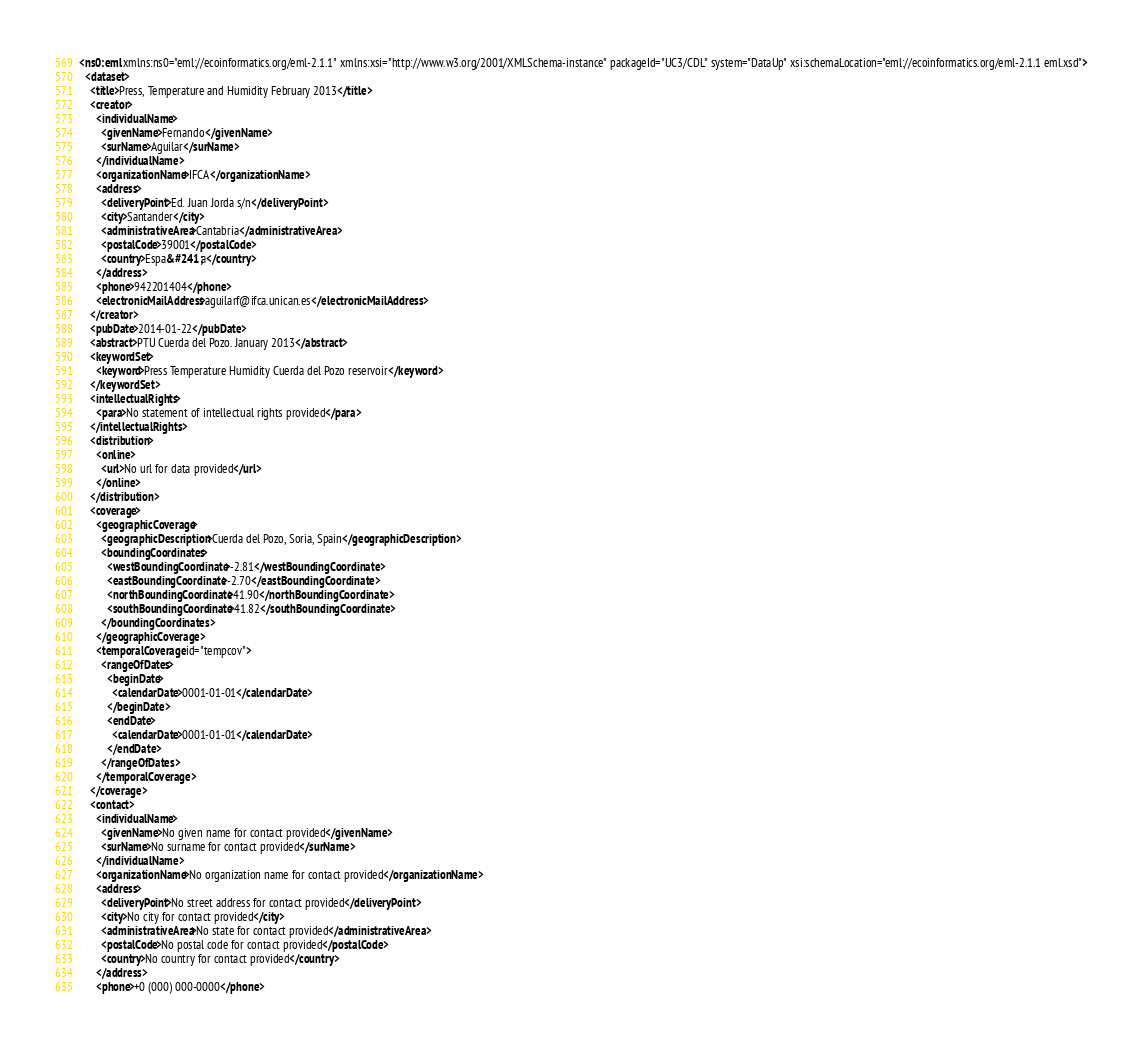Convert code to text. <code><loc_0><loc_0><loc_500><loc_500><_XML_><ns0:eml xmlns:ns0="eml://ecoinformatics.org/eml-2.1.1" xmlns:xsi="http://www.w3.org/2001/XMLSchema-instance" packageId="UC3/CDL" system="DataUp" xsi:schemaLocation="eml://ecoinformatics.org/eml-2.1.1 eml.xsd">
  <dataset>
    <title>Press, Temperature and Humidity February 2013</title>
    <creator>
      <individualName>
        <givenName>Fernando</givenName>
        <surName>Aguilar</surName>
      </individualName>
      <organizationName>IFCA</organizationName>
      <address>
        <deliveryPoint>Ed. Juan Jorda s/n</deliveryPoint>
        <city>Santander</city>
        <administrativeArea>Cantabria</administrativeArea>
        <postalCode>39001</postalCode>
        <country>Espa&#241;a</country>
      </address>
      <phone>942201404</phone>
      <electronicMailAddress>aguilarf@ifca.unican.es</electronicMailAddress>
    </creator>
    <pubDate>2014-01-22</pubDate>
    <abstract>PTU Cuerda del Pozo. January 2013</abstract>
    <keywordSet>
      <keyword>Press Temperature Humidity Cuerda del Pozo reservoir</keyword>
    </keywordSet>
    <intellectualRights>
      <para>No statement of intellectual rights provided</para>
    </intellectualRights>
    <distribution>
      <online>
        <url>No url for data provided</url>
      </online>
    </distribution>
    <coverage>
      <geographicCoverage>
        <geographicDescription>Cuerda del Pozo, Soria, Spain</geographicDescription>
        <boundingCoordinates>
          <westBoundingCoordinate>-2.81</westBoundingCoordinate>
          <eastBoundingCoordinate>-2.70</eastBoundingCoordinate>
          <northBoundingCoordinate>41.90</northBoundingCoordinate>
          <southBoundingCoordinate>41.82</southBoundingCoordinate>
        </boundingCoordinates>
      </geographicCoverage>
      <temporalCoverage id="tempcov">
        <rangeOfDates>
          <beginDate>
            <calendarDate>0001-01-01</calendarDate>
          </beginDate>
          <endDate>
            <calendarDate>0001-01-01</calendarDate>
          </endDate>
        </rangeOfDates>
      </temporalCoverage>
    </coverage>
    <contact>
      <individualName>
        <givenName>No given name for contact provided</givenName>
        <surName>No surname for contact provided</surName>
      </individualName>
      <organizationName>No organization name for contact provided</organizationName>
      <address>
        <deliveryPoint>No street address for contact provided</deliveryPoint>
        <city>No city for contact provided</city>
        <administrativeArea>No state for contact provided</administrativeArea>
        <postalCode>No postal code for contact provided</postalCode>
        <country>No country for contact provided</country>
      </address>
      <phone>+0 (000) 000-0000</phone></code> 